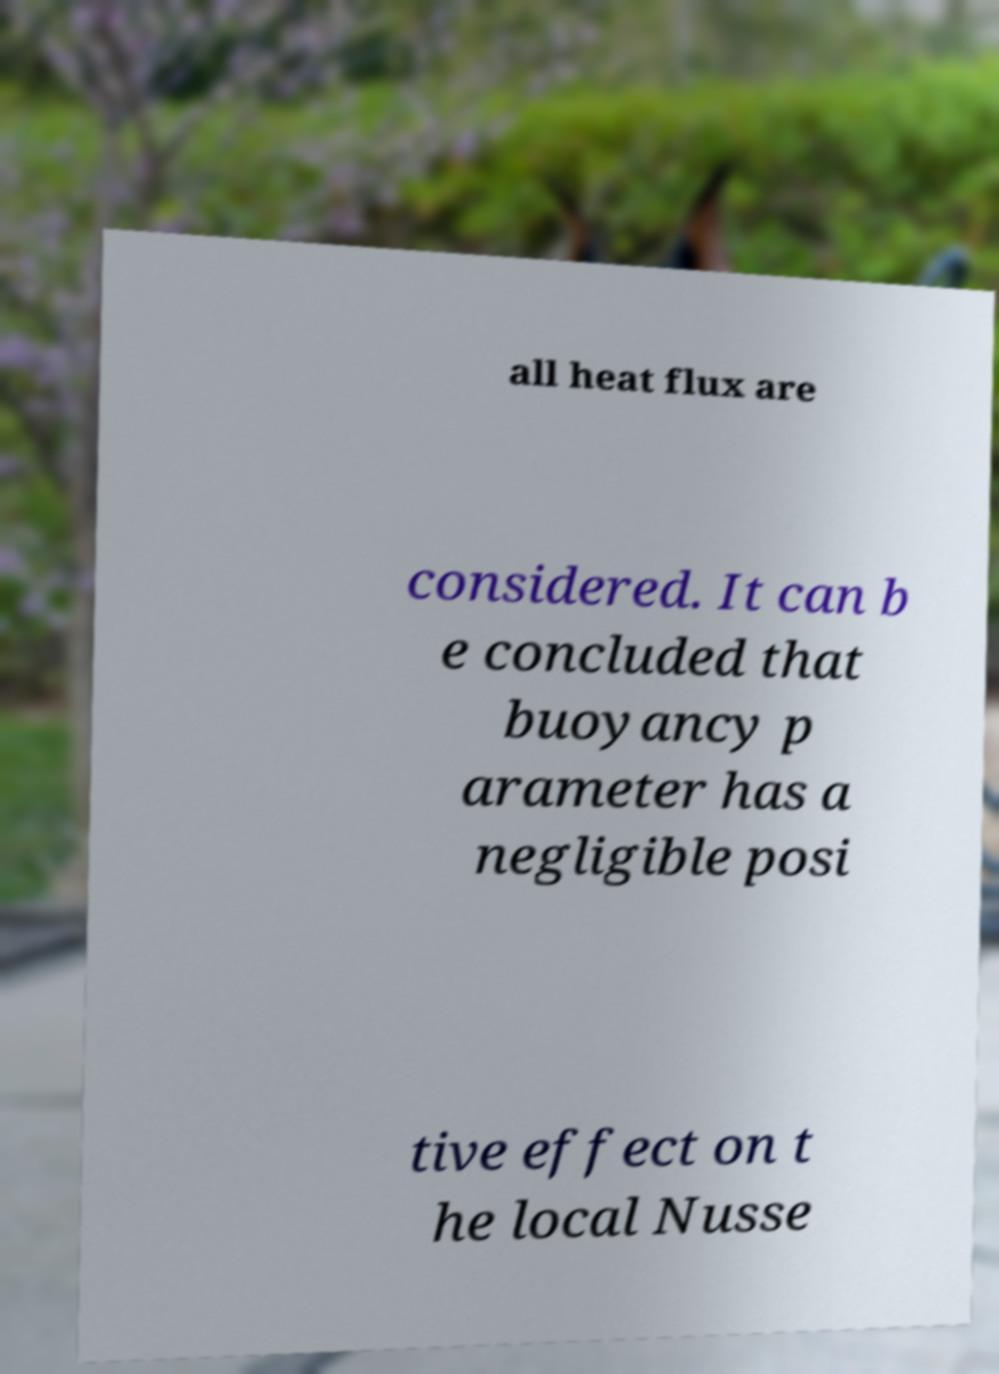Please read and relay the text visible in this image. What does it say? all heat flux are considered. It can b e concluded that buoyancy p arameter has a negligible posi tive effect on t he local Nusse 